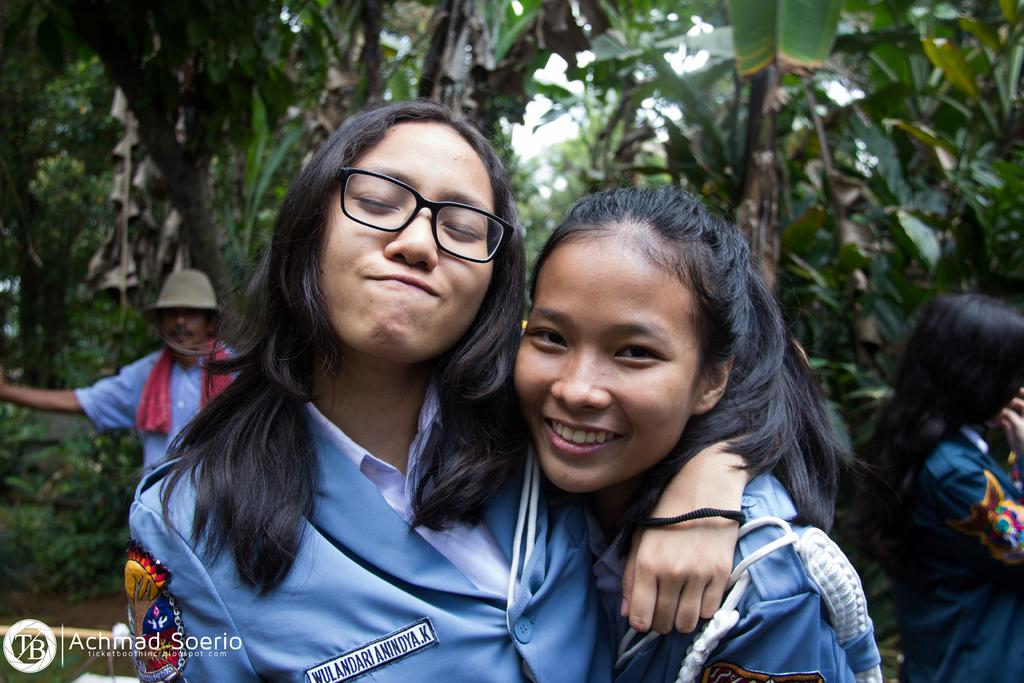What is the main subject of the image? There is a girl in the image. Can you describe the girl's appearance? The girl is wearing spectacles on the right side. Are there any other people in the image? Yes, there is another girl in the image. How is the second girl feeling or expressing herself? The second girl is laughing. What can be seen in the background of the image? There are banana trees in the background of the image. What type of knee injury can be seen on the girl in the image? There is no knee injury visible on the girl in the image. Is the image set in a hot environment? The image does not provide any information about the temperature or environment, so it cannot be determined if it is hot. 